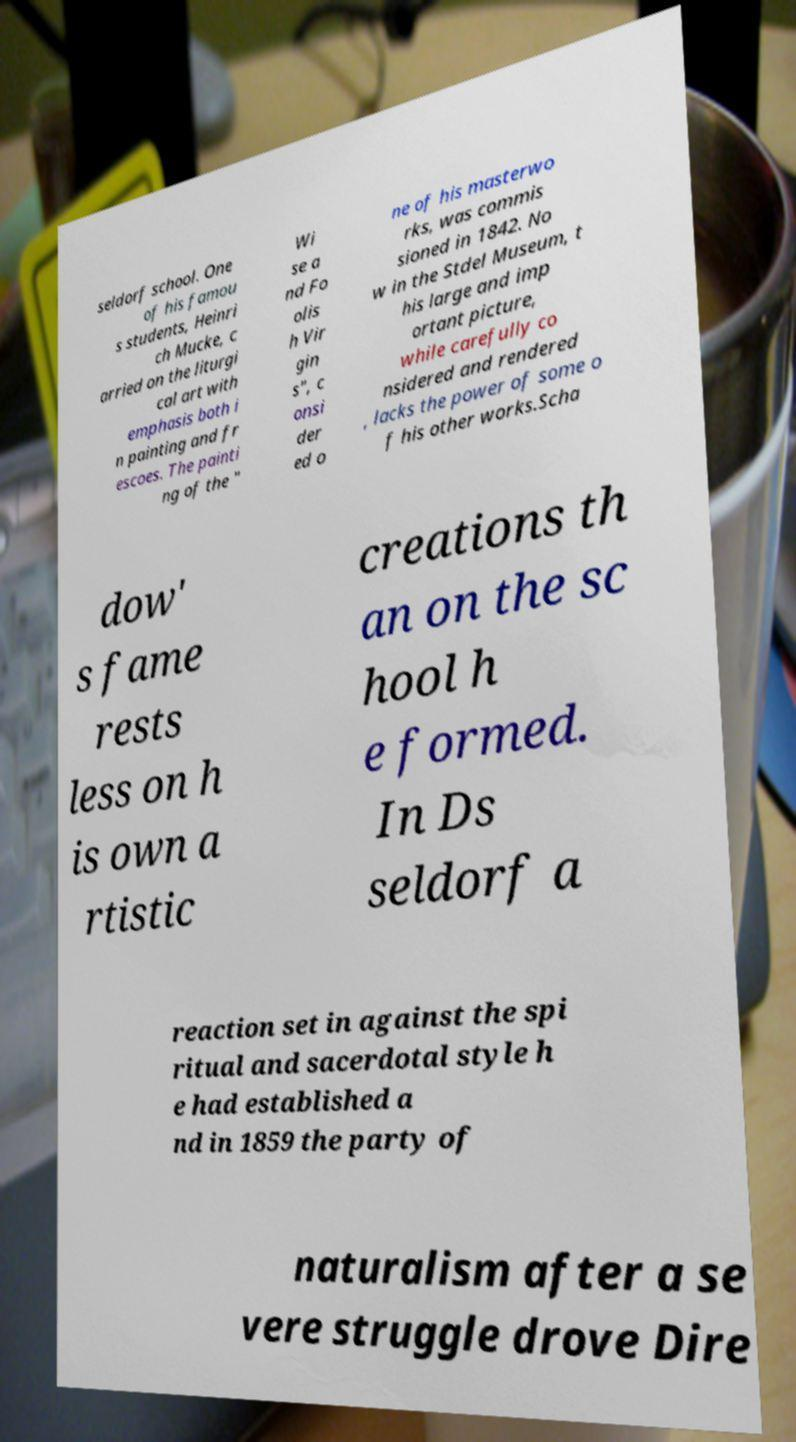Please read and relay the text visible in this image. What does it say? seldorf school. One of his famou s students, Heinri ch Mucke, c arried on the liturgi cal art with emphasis both i n painting and fr escoes. The painti ng of the " Wi se a nd Fo olis h Vir gin s", c onsi der ed o ne of his masterwo rks, was commis sioned in 1842. No w in the Stdel Museum, t his large and imp ortant picture, while carefully co nsidered and rendered , lacks the power of some o f his other works.Scha dow' s fame rests less on h is own a rtistic creations th an on the sc hool h e formed. In Ds seldorf a reaction set in against the spi ritual and sacerdotal style h e had established a nd in 1859 the party of naturalism after a se vere struggle drove Dire 